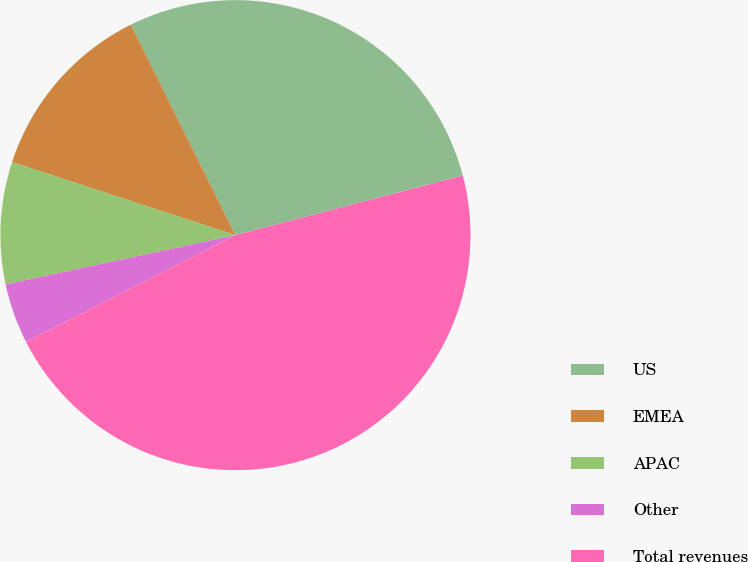<chart> <loc_0><loc_0><loc_500><loc_500><pie_chart><fcel>US<fcel>EMEA<fcel>APAC<fcel>Other<fcel>Total revenues<nl><fcel>28.26%<fcel>12.63%<fcel>8.39%<fcel>4.15%<fcel>46.57%<nl></chart> 